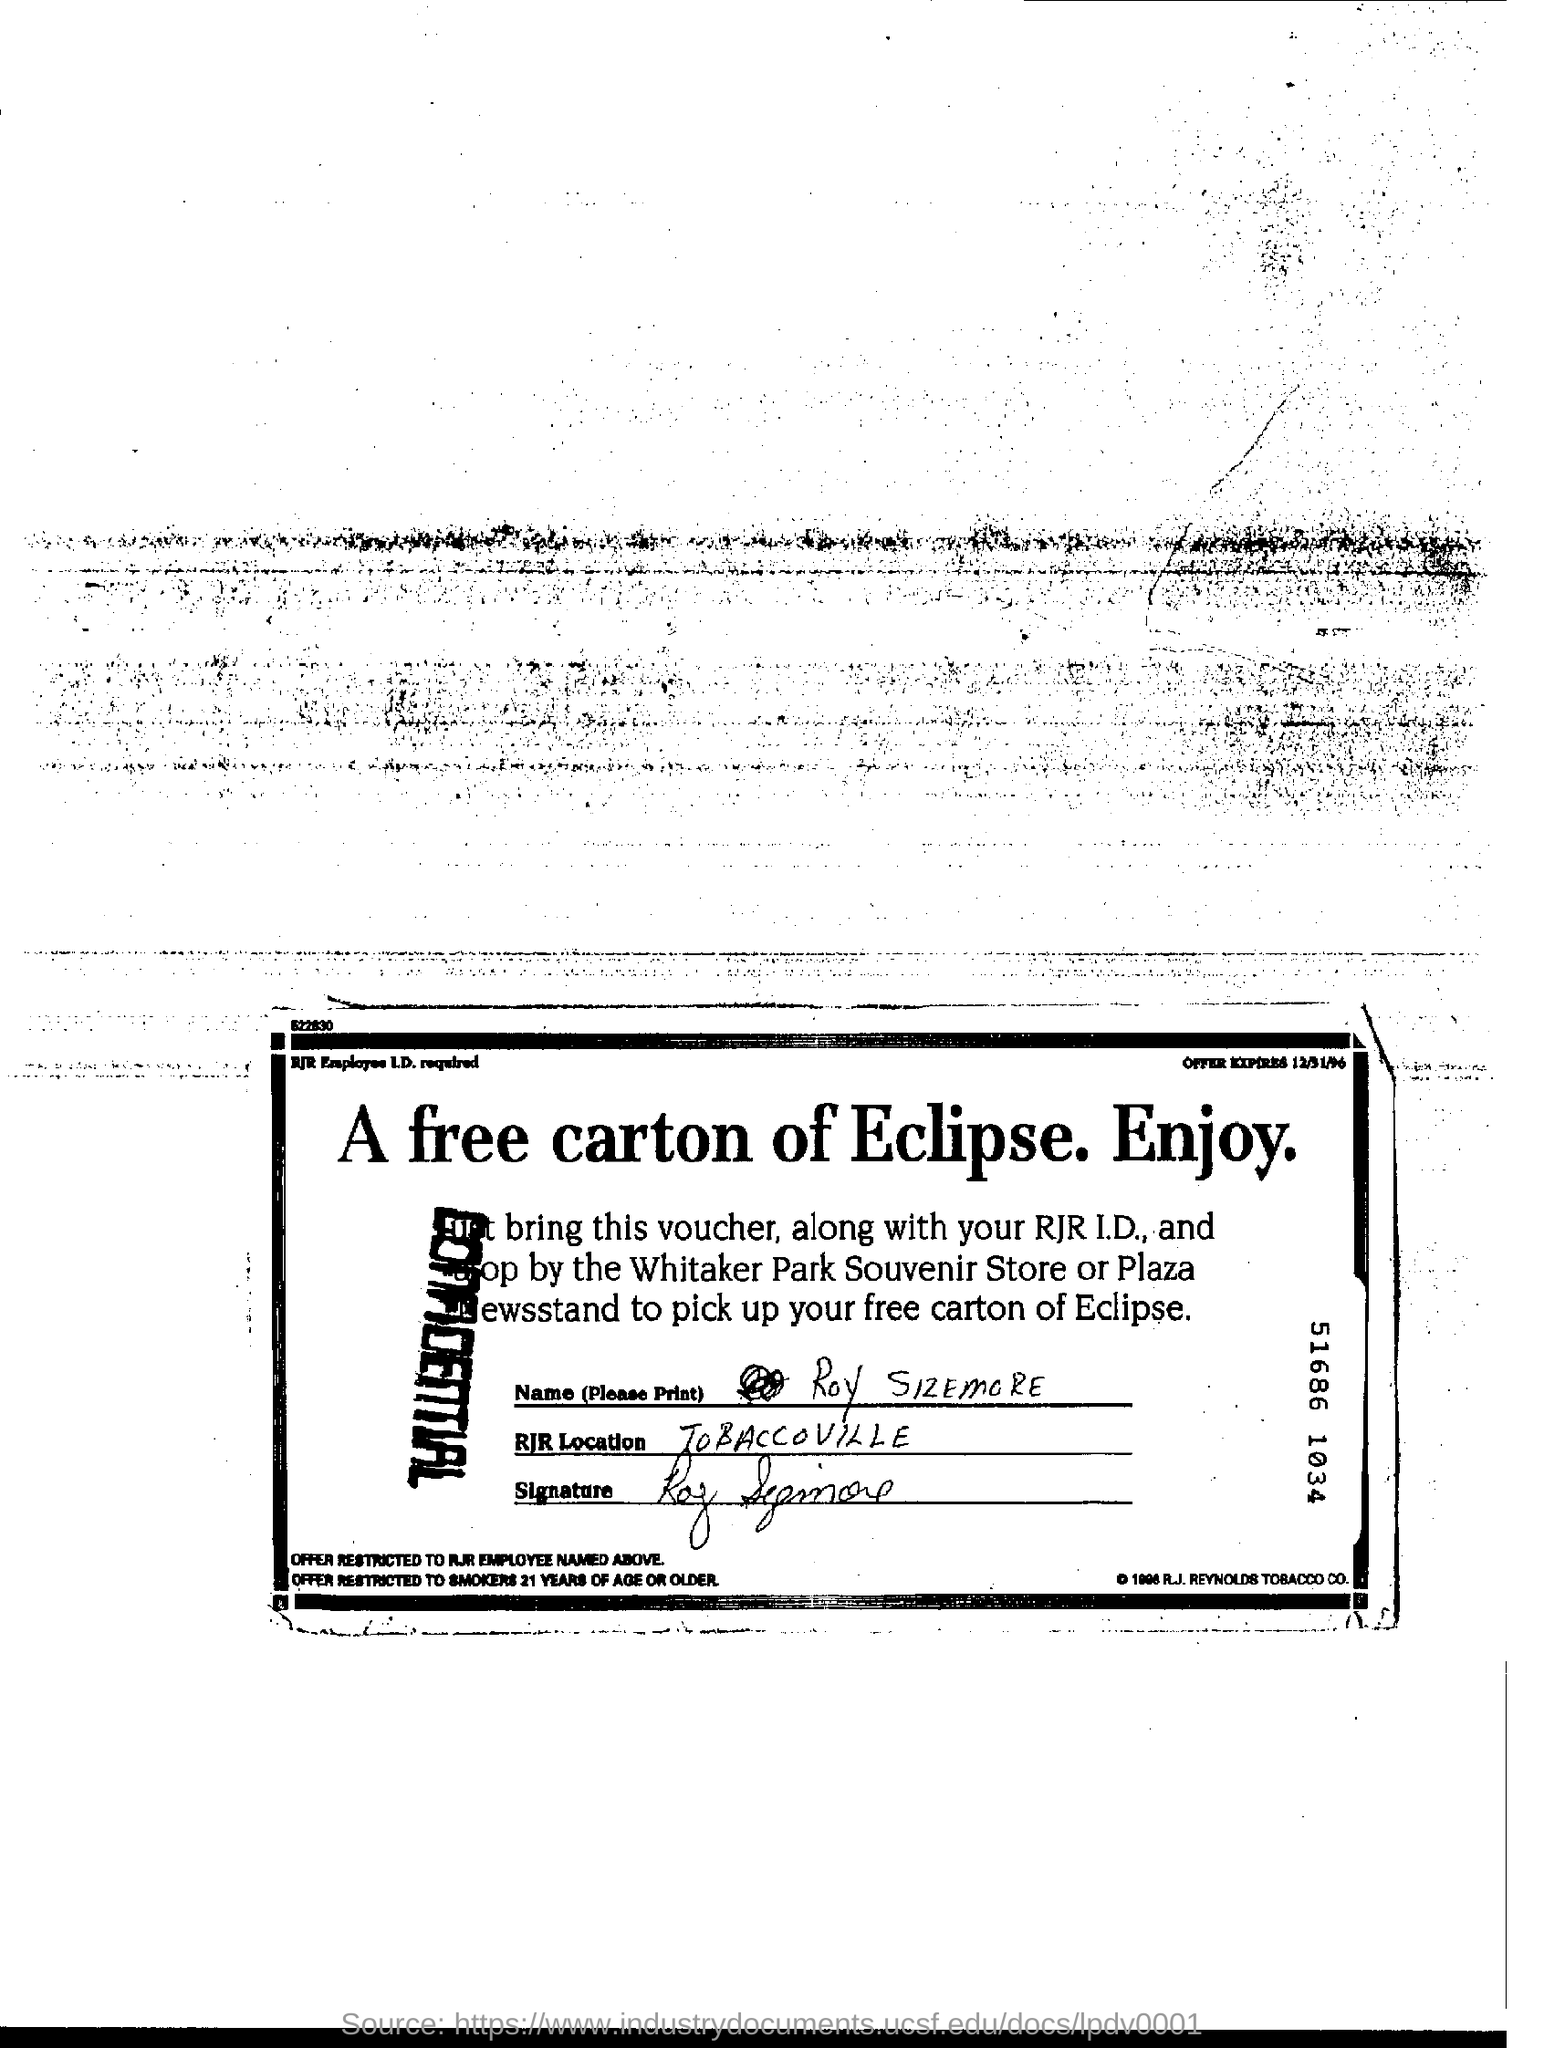Indicate a few pertinent items in this graphic. The RJR Location is in TOBACCOVILLE. I received a free carton of Eclipse cigarette brand which was offered. 